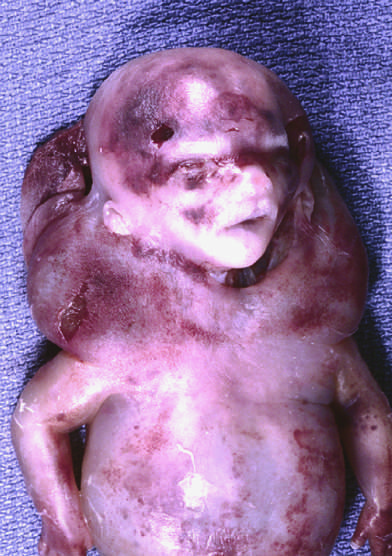s this condition cystic hygroma?
Answer the question using a single word or phrase. Yes 